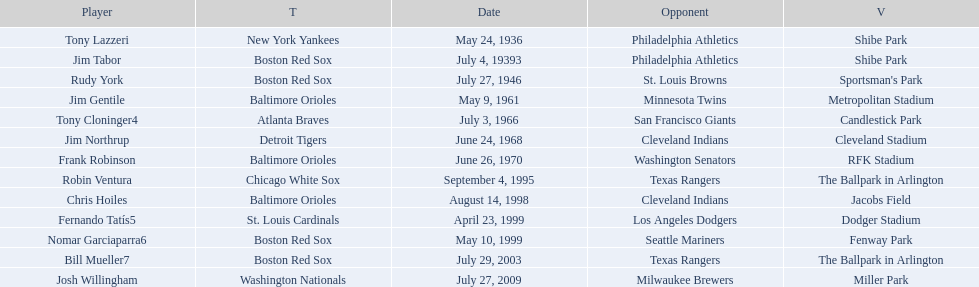What venue did detroit play cleveland in? Cleveland Stadium. Who was the player? Jim Northrup. What date did they play? June 24, 1968. 